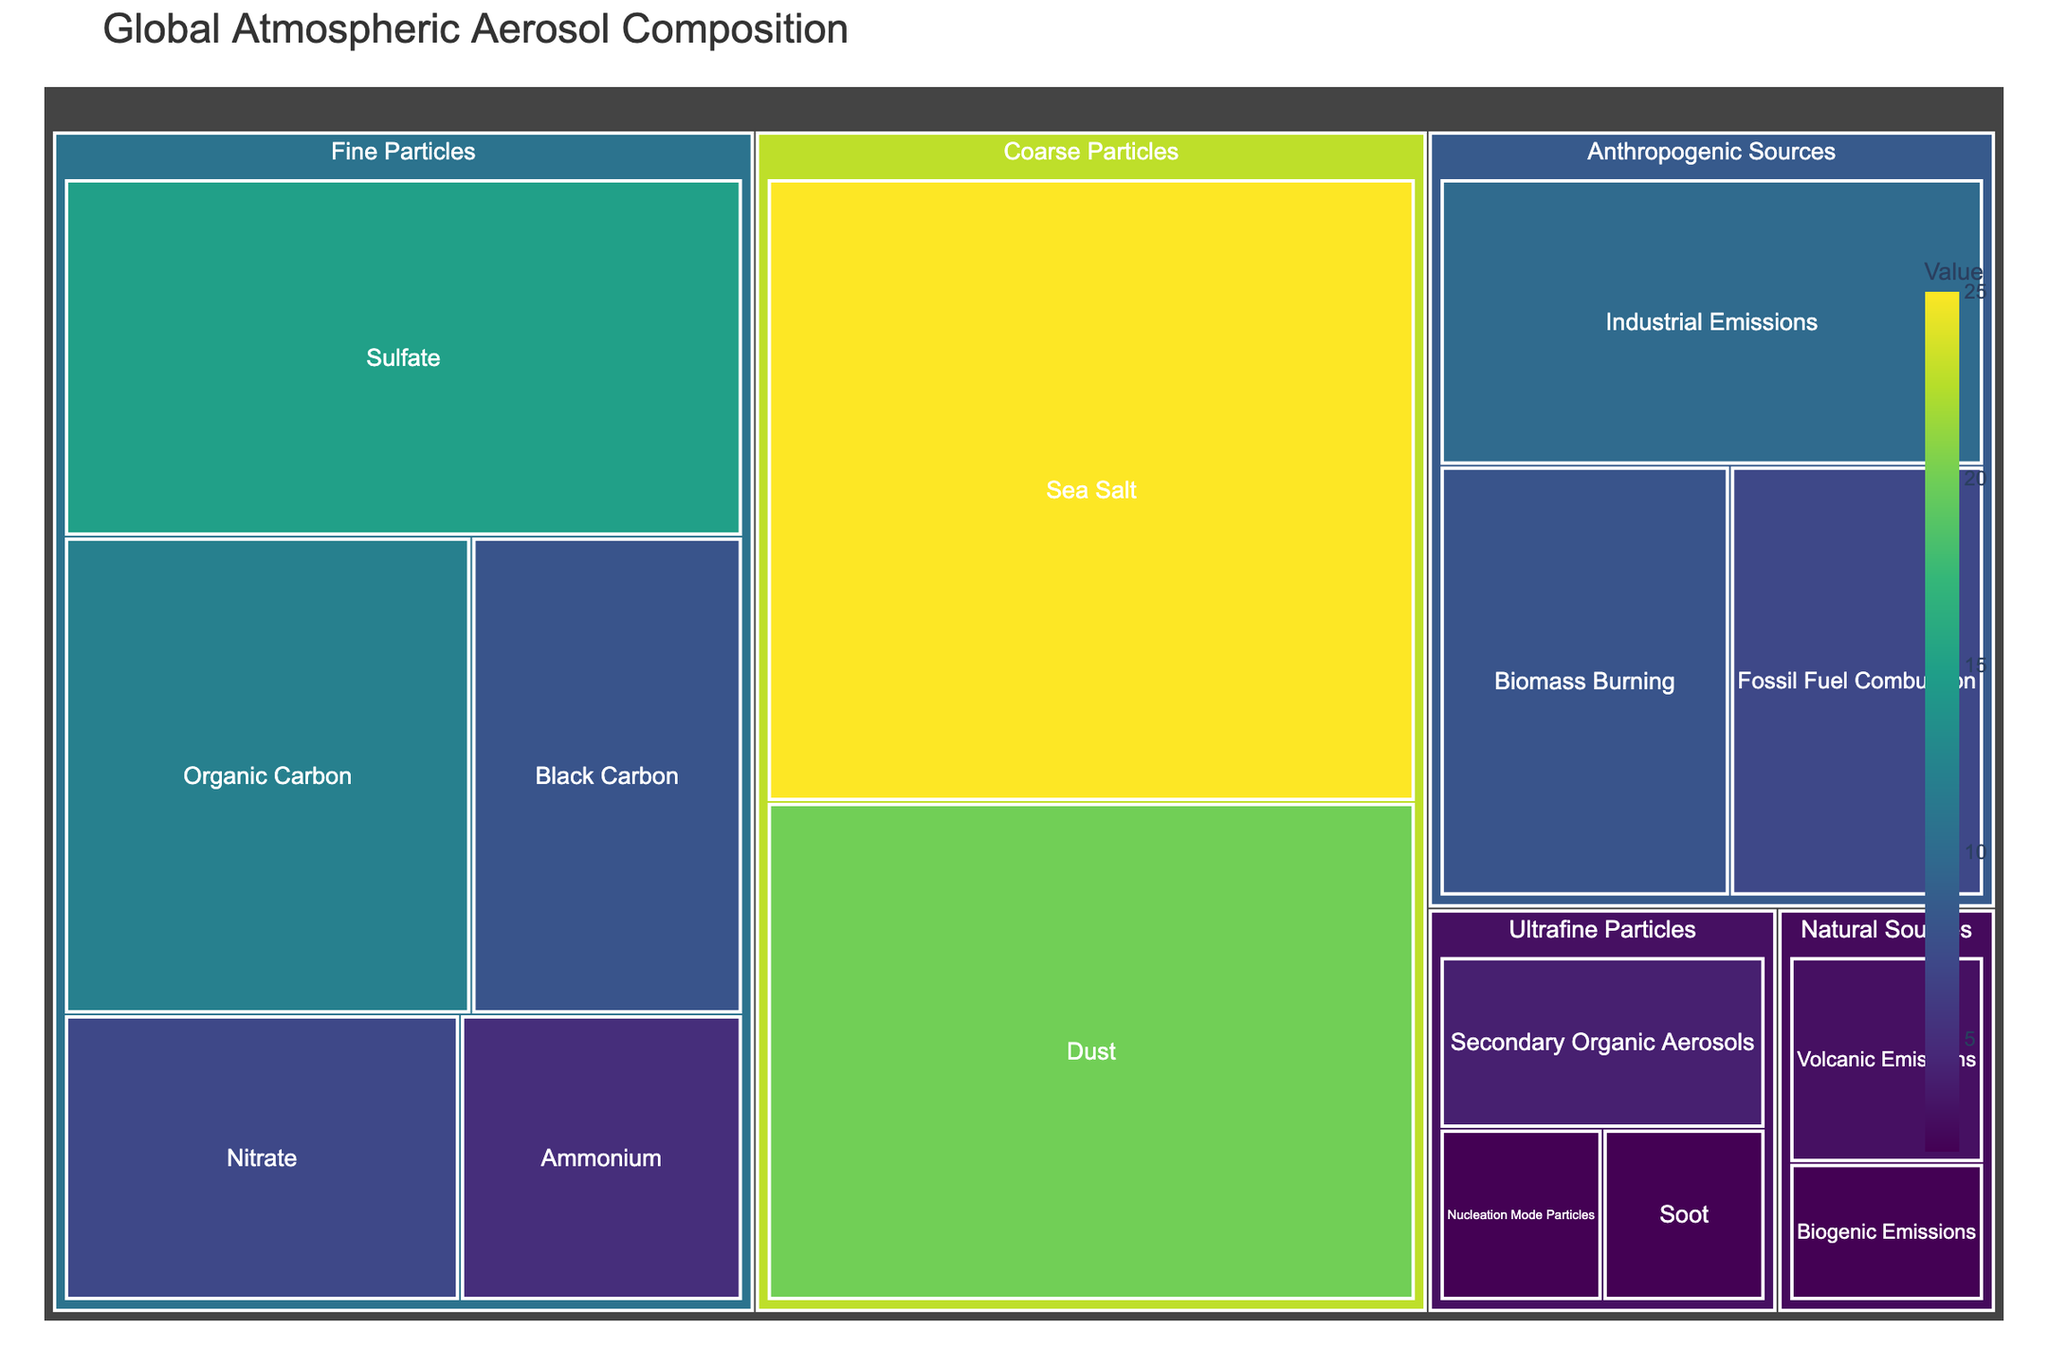What's the title of the treemap? The title is typically located at the top of the figure. In this case, it is specified as 'Global Atmospheric Aerosol Composition'.
Answer: Global Atmospheric Aerosol Composition Which subcategory under 'Fine Particles' has the highest value? From the treemap, you can see that under 'Fine Particles', 'Sulfate' has the highest value, visually represented as the largest area.
Answer: Sulfate What is the combined value of 'Coarse Particles' subcategories? Sum the values of 'Sea Salt' (25) and 'Dust' (20) under 'Coarse Particles'. 25 + 20 = 45
Answer: 45 How does the value of 'Industrial Emissions' compare to 'Biomass Burning' within 'Anthropogenic Sources'? From the treemap, the values of 'Industrial Emissions' and 'Biomass Burning' are 10 and 8 respectively. 10 is greater than 8.
Answer: Industrial Emissions > Biomass Burning Which category contributes the least to the global aerosol composition? Each primary category can be quickly identified by area size. 'Natural Sources' appears to be the smallest, confirmed by the presence of 'Volanic Emissions' (3) and 'Biogenic Emissions' (2).
Answer: Natural Sources Are there more fine particles or ultrafine particles in terms of the number of subcategories? Count the subcategories under 'Fine Particles' and 'Ultrafine Particles'. 'Fine Particles' have six subcategories, and 'Ultrafine Particles' have three.
Answer: Fine Particles What percentage of 'Anthropogenic Sources' is made up of 'Fossil Fuel Combustion'? Sum the values of 'Industrial Emissions', 'Biomass Burning', and 'Fossil Fuel Combustion' (10+8+7=25). 'Fossil Fuel Combustion' contribution is 7. Percentage: (7/25) * 100 = 28%
Answer: 28% Which has a larger value: 'Black Carbon' or 'Nitrate'? From the treemap, 'Black Carbon' has a value of 8 and 'Nitrate' has a value of 7. Comparatively, 8 is greater than 7.
Answer: Black Carbon What is the total value of all subcategories under 'Natural Sources'? Add the values of 'Volcanic Emissions' (3) and 'Biogenic Emissions' (2) under 'Natural Sources'. 3 + 2 = 5
Answer: 5 